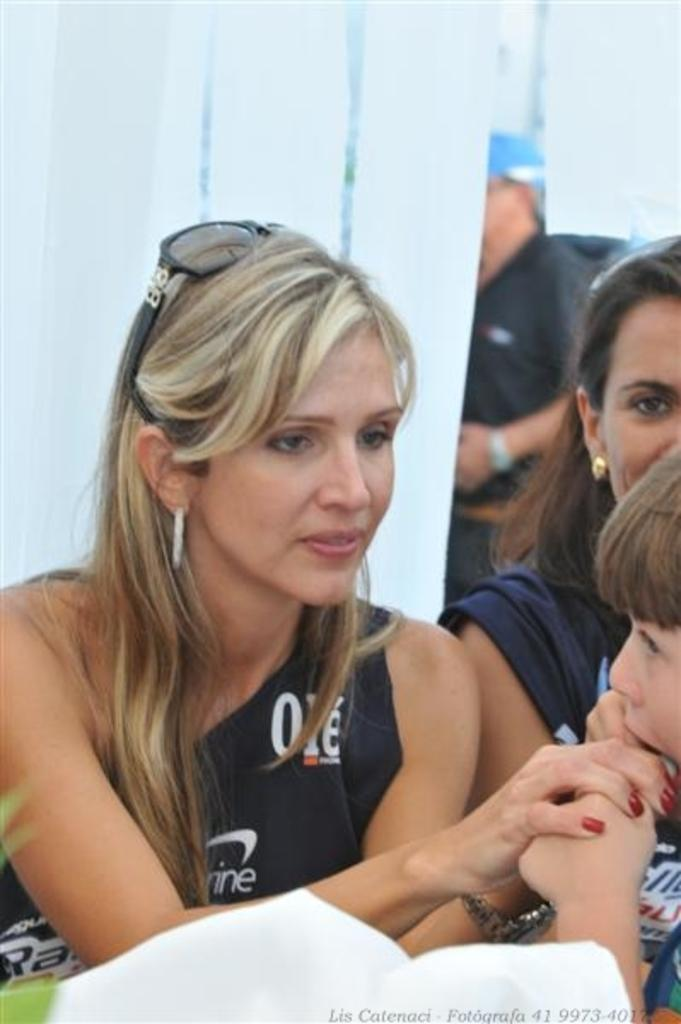Who or what is present in the image? There are people in the image. What color or type of objects can be seen in the image? There are white objects in the image. Is there any additional information or marking on the image? Yes, there is a watermark at the bottom of the image. What kind of reward does the daughter receive in the image? There is no daughter present in the image, and therefore no reward can be observed. What type of curve can be seen in the image? There is no curve present in the image; it features people and white objects. 